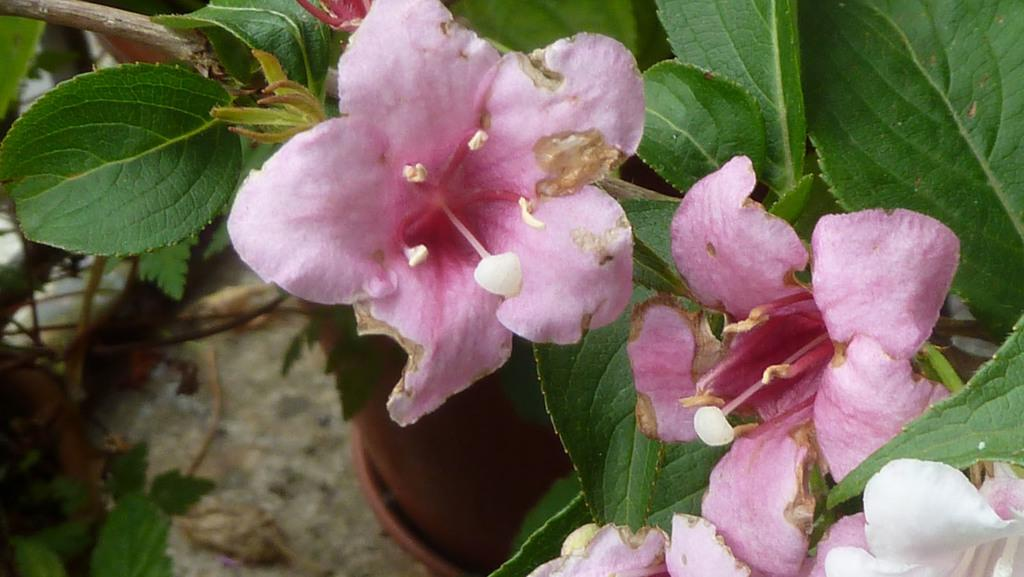What type of plants can be seen in the image? There are flowers and leaves in the image. Can you describe the appearance of the flowers? Unfortunately, the specific appearance of the flowers cannot be determined from the provided facts. What is the relationship between the flowers and leaves in the image? The flowers and leaves are likely part of the same plant or plants, as they are both present in the image. How many wounds can be seen on the flowers in the image? There are no wounds present on the flowers in the image, as the provided facts do not mention any damage or injury to the flowers. 